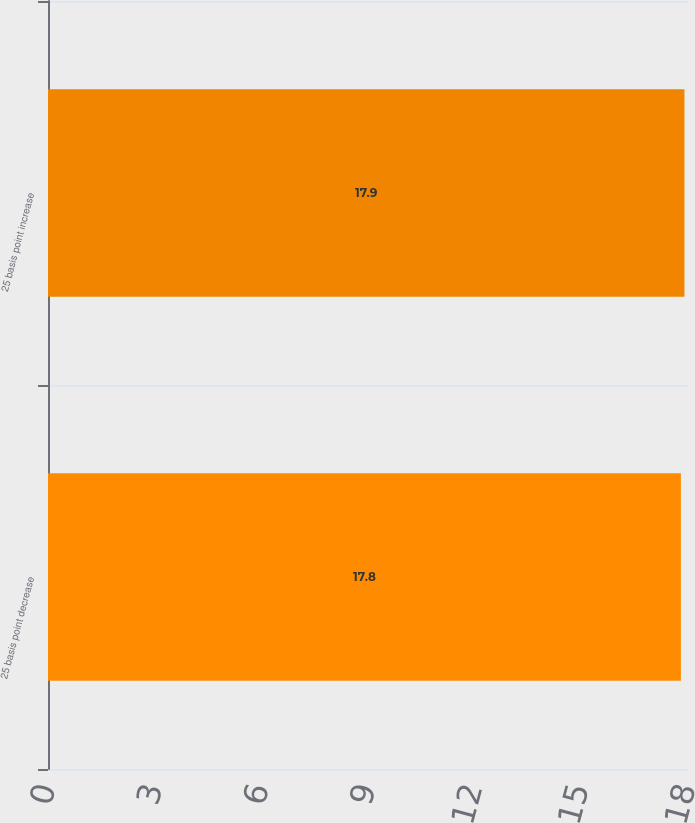Convert chart. <chart><loc_0><loc_0><loc_500><loc_500><bar_chart><fcel>25 basis point decrease<fcel>25 basis point increase<nl><fcel>17.8<fcel>17.9<nl></chart> 